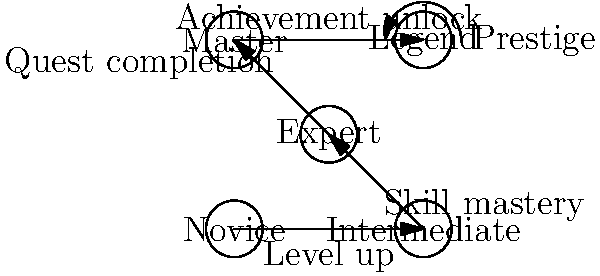In the given state diagram representing a player progression system for a role-playing game, what is the minimum number of state transitions required for a player to reach the "Legend" status from the "Novice" state? To answer this question, we need to analyze the state diagram and count the minimum number of transitions required to reach the "Legend" state from the "Novice" state. Let's break it down step-by-step:

1. The diagram shows five states: Novice, Intermediate, Expert, Master, and Legend.

2. The transitions between states are as follows:
   - Novice to Intermediate: Level up
   - Intermediate to Expert: Skill mastery
   - Expert to Master: Quest completion
   - Master to Legend: Achievement unlock

3. To reach the "Legend" state from "Novice", a player must progress through each intermediate state in order:
   a) Novice → Intermediate
   b) Intermediate → Expert
   c) Expert → Master
   d) Master → Legend

4. Each transition represents one step in the progression system.

5. Counting these transitions, we can see that there are exactly 4 transitions required to move from "Novice" to "Legend".

6. Note that the "Prestige" transition from Legend back to itself is not relevant for this question, as we are only concerned with reaching the Legend state for the first time.

Therefore, the minimum number of state transitions required for a player to reach the "Legend" status from the "Novice" state is 4.
Answer: 4 